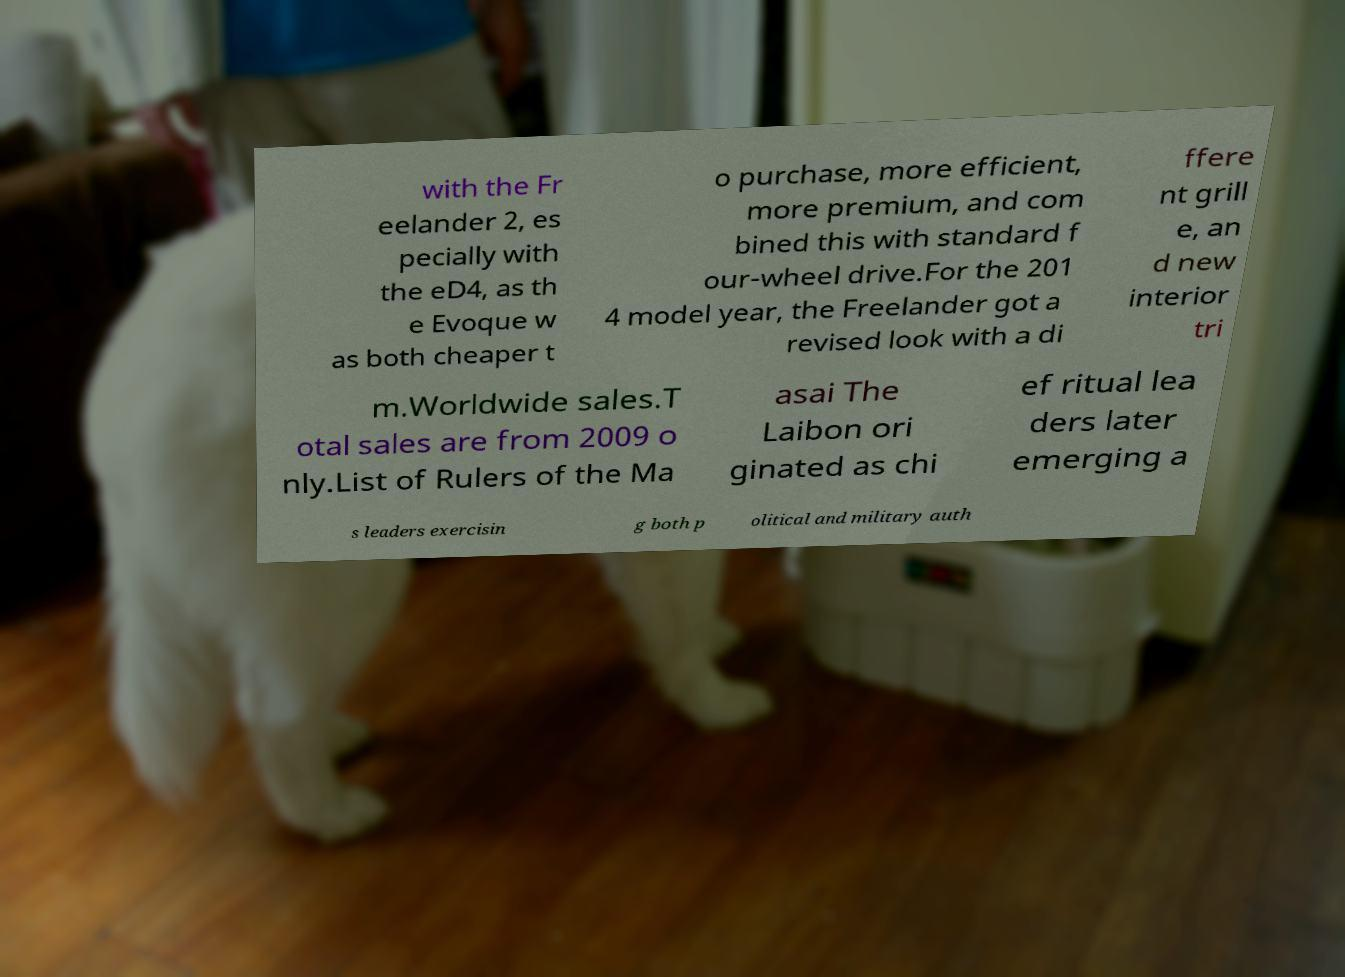Please identify and transcribe the text found in this image. with the Fr eelander 2, es pecially with the eD4, as th e Evoque w as both cheaper t o purchase, more efficient, more premium, and com bined this with standard f our-wheel drive.For the 201 4 model year, the Freelander got a revised look with a di ffere nt grill e, an d new interior tri m.Worldwide sales.T otal sales are from 2009 o nly.List of Rulers of the Ma asai The Laibon ori ginated as chi ef ritual lea ders later emerging a s leaders exercisin g both p olitical and military auth 